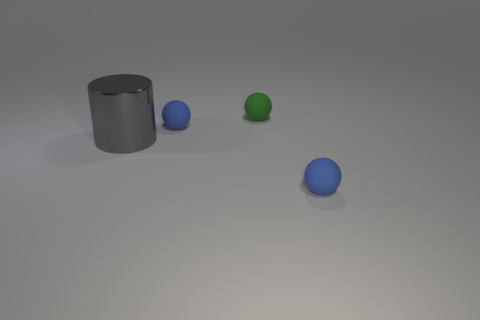Add 2 blue balls. How many objects exist? 6 Subtract all spheres. How many objects are left? 1 Add 4 blue matte objects. How many blue matte objects exist? 6 Subtract 0 cyan blocks. How many objects are left? 4 Subtract all green matte things. Subtract all brown metallic balls. How many objects are left? 3 Add 3 tiny objects. How many tiny objects are left? 6 